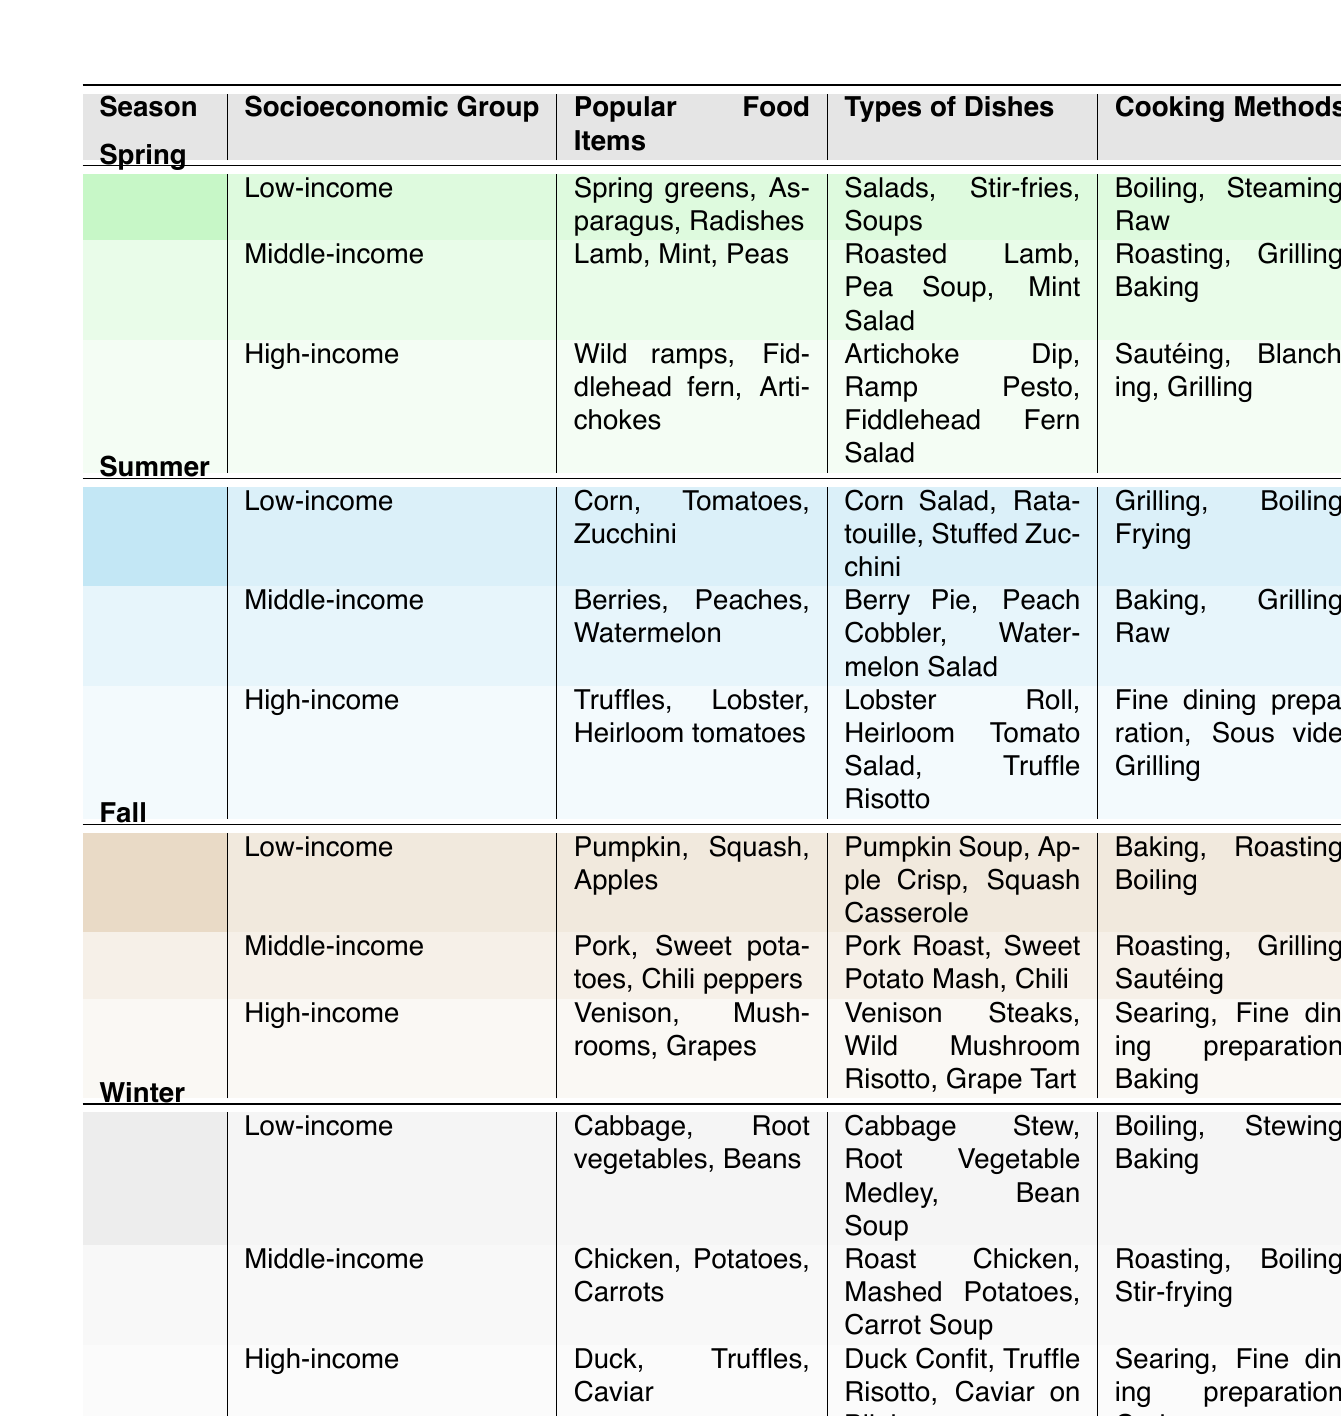What are the popular food items for the high-income group in winter? The table shows that in winter, the high-income group's popular food items are Duck, Truffles, and Caviar.
Answer: Duck, Truffles, Caviar Which socioeconomic group features sweet potatoes in the fall? By examining the fall section of the table, we see that sweet potatoes are popular among the middle-income group.
Answer: Middle-income True or False: Cabbage is a popular food item for the high-income group during any season. Looking at the data, cabbage is only listed for the low-income group in winter, indicating it is not popular among the high-income group.
Answer: False What types of dishes do low-income and high-income groups prefer in spring? For the low-income group in spring, the types of dishes are Salads, Stir-fries, and Soups. For the high-income group, the types of dishes are Artichoke Dip, Ramp Pesto, and Fiddlehead Fern Salad.
Answer: Salads, Stir-fries, Soups; Artichoke Dip, Ramp Pesto, Fiddlehead Fern Salad What cooking method is common for both the low-income and middle-income groups during summer? The summer section shows that grilling is a cooking method for both. The low-income group's methods include Grilling, Boiling, and Frying, while the middle-income group uses Baking, Grilling, and Raw.
Answer: Grilling Which season has the highest variety of popular food items across all socioeconomic groups? In the table, each season has three groups with three food items each, leading to a variety of 9 food items per season. Therefore, there is an equal variety across all seasons.
Answer: All seasons have equal variety True or False: Lamb is a popular food item for the low-income group in spring. Checking the table reveals that lamb is specifically listed under the middle-income group, not low-income, confirming that the statement is false.
Answer: False How does the cooking method for the middle-income group's winter dishes differ from those in spring? In winter, the middle-income group's cooking methods include Roasting, Boiling, and Stir-frying, while in spring, they include Roasting, Grilling, and Baking. The difference is that Stir-frying is exclusive to winter, whereas Grilling is exclusive to spring.
Answer: Different methods include Stir-frying in winter and Grilling in spring 